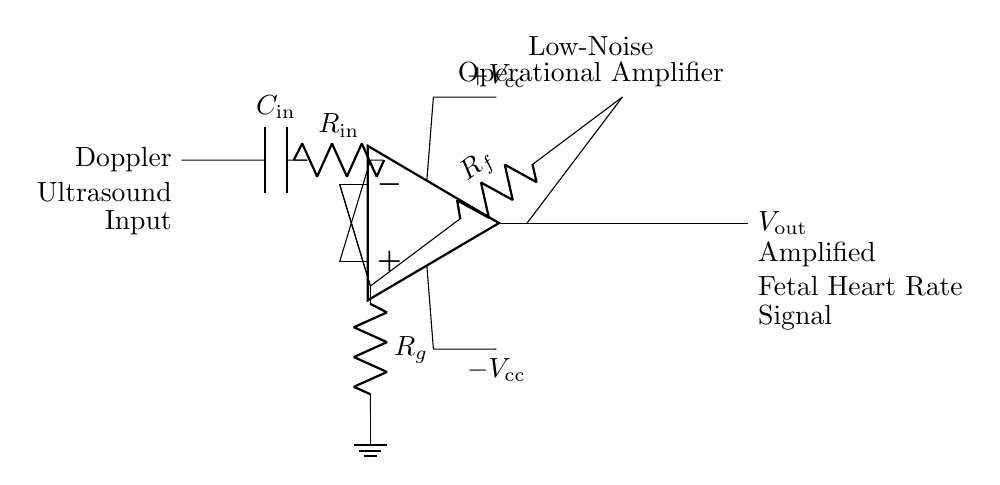What type of amplifier is shown in the circuit? The circuit is a low-noise operational amplifier, indicated by the label above the op-amp symbol.
Answer: low-noise operational amplifier What is the input component labeled in the circuit? The input component is a capacitor, denoted by the symbol "C" with the label "C_in" next to it.
Answer: Capacitor What is the feedback resistor in the circuit? The feedback resistor is labeled "R_f" and is connected between the output of the op-amp and its inverting input terminal.
Answer: R_f What is the power supply voltage range for this op-amp circuit? The power supply voltage is labeled as "+V_cc" and "-V_cc", indicating the circuit is powered with both positive and negative voltages.
Answer: +V_cc and -V_cc How does the output signal represent fetal heart rate? The output signal, labeled as "V_out", is the amplified signal which is derived from the input obtained from the Doppler ultrasound, effectively corresponding to the fetal heart rate fluctuations.
Answer: Amplified fetal heart rate signal What is the purpose of the capacitor at the input of the circuit? The capacitor at the input serves to filter high-frequency noise and allows the AC components of the fetal heart rate signal to pass through while blocking DC components.
Answer: Noise filtering How does gaining an operational amplifier influence the output signal? The operational amplifier amplifies the input signal based on the gain set by the feedback resistor "R_f" and the input resistor "R_in", thus increasing the amplitude of the fetal heart rate signal for better detection.
Answer: Increases signal amplitude 